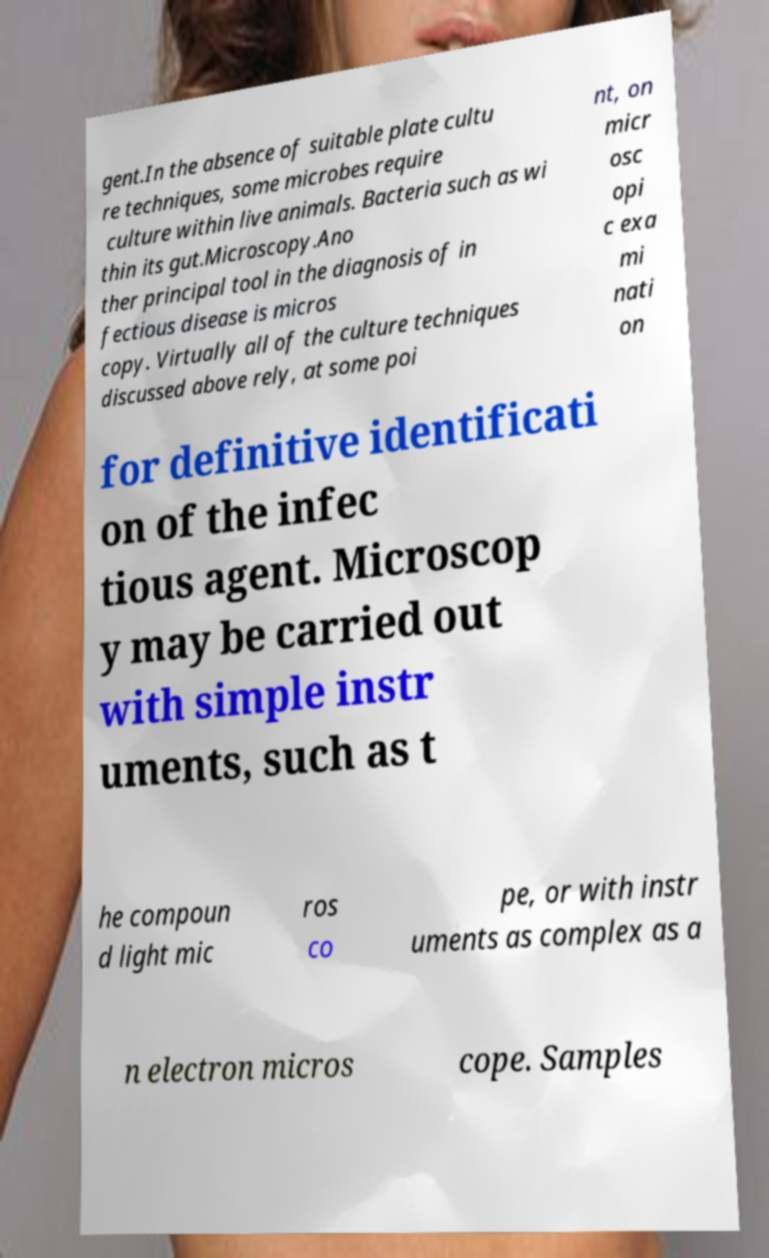There's text embedded in this image that I need extracted. Can you transcribe it verbatim? gent.In the absence of suitable plate cultu re techniques, some microbes require culture within live animals. Bacteria such as wi thin its gut.Microscopy.Ano ther principal tool in the diagnosis of in fectious disease is micros copy. Virtually all of the culture techniques discussed above rely, at some poi nt, on micr osc opi c exa mi nati on for definitive identificati on of the infec tious agent. Microscop y may be carried out with simple instr uments, such as t he compoun d light mic ros co pe, or with instr uments as complex as a n electron micros cope. Samples 